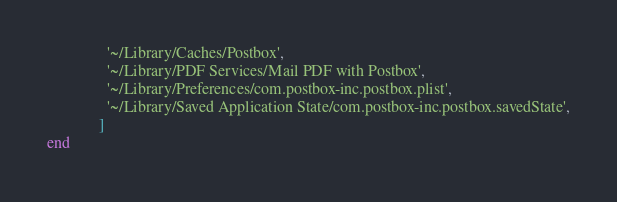<code> <loc_0><loc_0><loc_500><loc_500><_Ruby_>               '~/Library/Caches/Postbox',
               '~/Library/PDF Services/Mail PDF with Postbox',
               '~/Library/Preferences/com.postbox-inc.postbox.plist',
               '~/Library/Saved Application State/com.postbox-inc.postbox.savedState',
             ]
end
</code> 